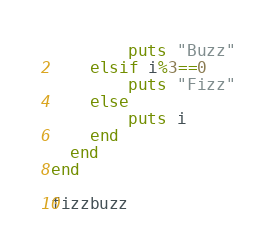<code> <loc_0><loc_0><loc_500><loc_500><_Ruby_>        puts "Buzz"
    elsif i%3==0
        puts "Fizz"
    else
        puts i
    end
  end
end

fizzbuzz</code> 